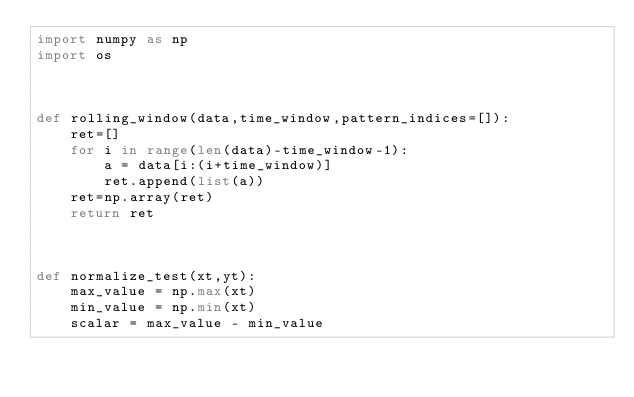Convert code to text. <code><loc_0><loc_0><loc_500><loc_500><_Python_>import numpy as np
import os



def rolling_window(data,time_window,pattern_indices=[]):
    ret=[]
    for i in range(len(data)-time_window-1):
        a = data[i:(i+time_window)]
        ret.append(list(a))
    ret=np.array(ret)
    return ret



def normalize_test(xt,yt):
    max_value = np.max(xt)
    min_value = np.min(xt)
    scalar = max_value - min_value</code> 